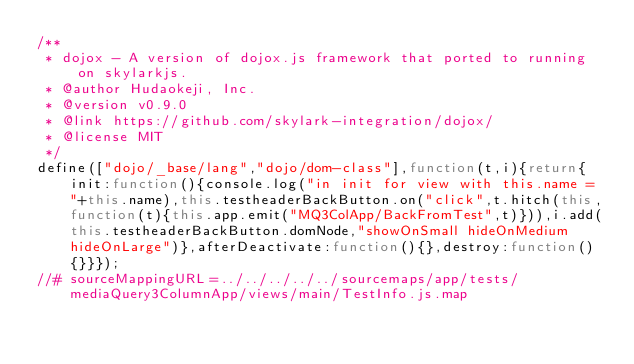Convert code to text. <code><loc_0><loc_0><loc_500><loc_500><_JavaScript_>/**
 * dojox - A version of dojox.js framework that ported to running on skylarkjs.
 * @author Hudaokeji, Inc.
 * @version v0.9.0
 * @link https://github.com/skylark-integration/dojox/
 * @license MIT
 */
define(["dojo/_base/lang","dojo/dom-class"],function(t,i){return{init:function(){console.log("in init for view with this.name = "+this.name),this.testheaderBackButton.on("click",t.hitch(this,function(t){this.app.emit("MQ3ColApp/BackFromTest",t)})),i.add(this.testheaderBackButton.domNode,"showOnSmall hideOnMedium hideOnLarge")},afterDeactivate:function(){},destroy:function(){}}});
//# sourceMappingURL=../../../../../sourcemaps/app/tests/mediaQuery3ColumnApp/views/main/TestInfo.js.map
</code> 